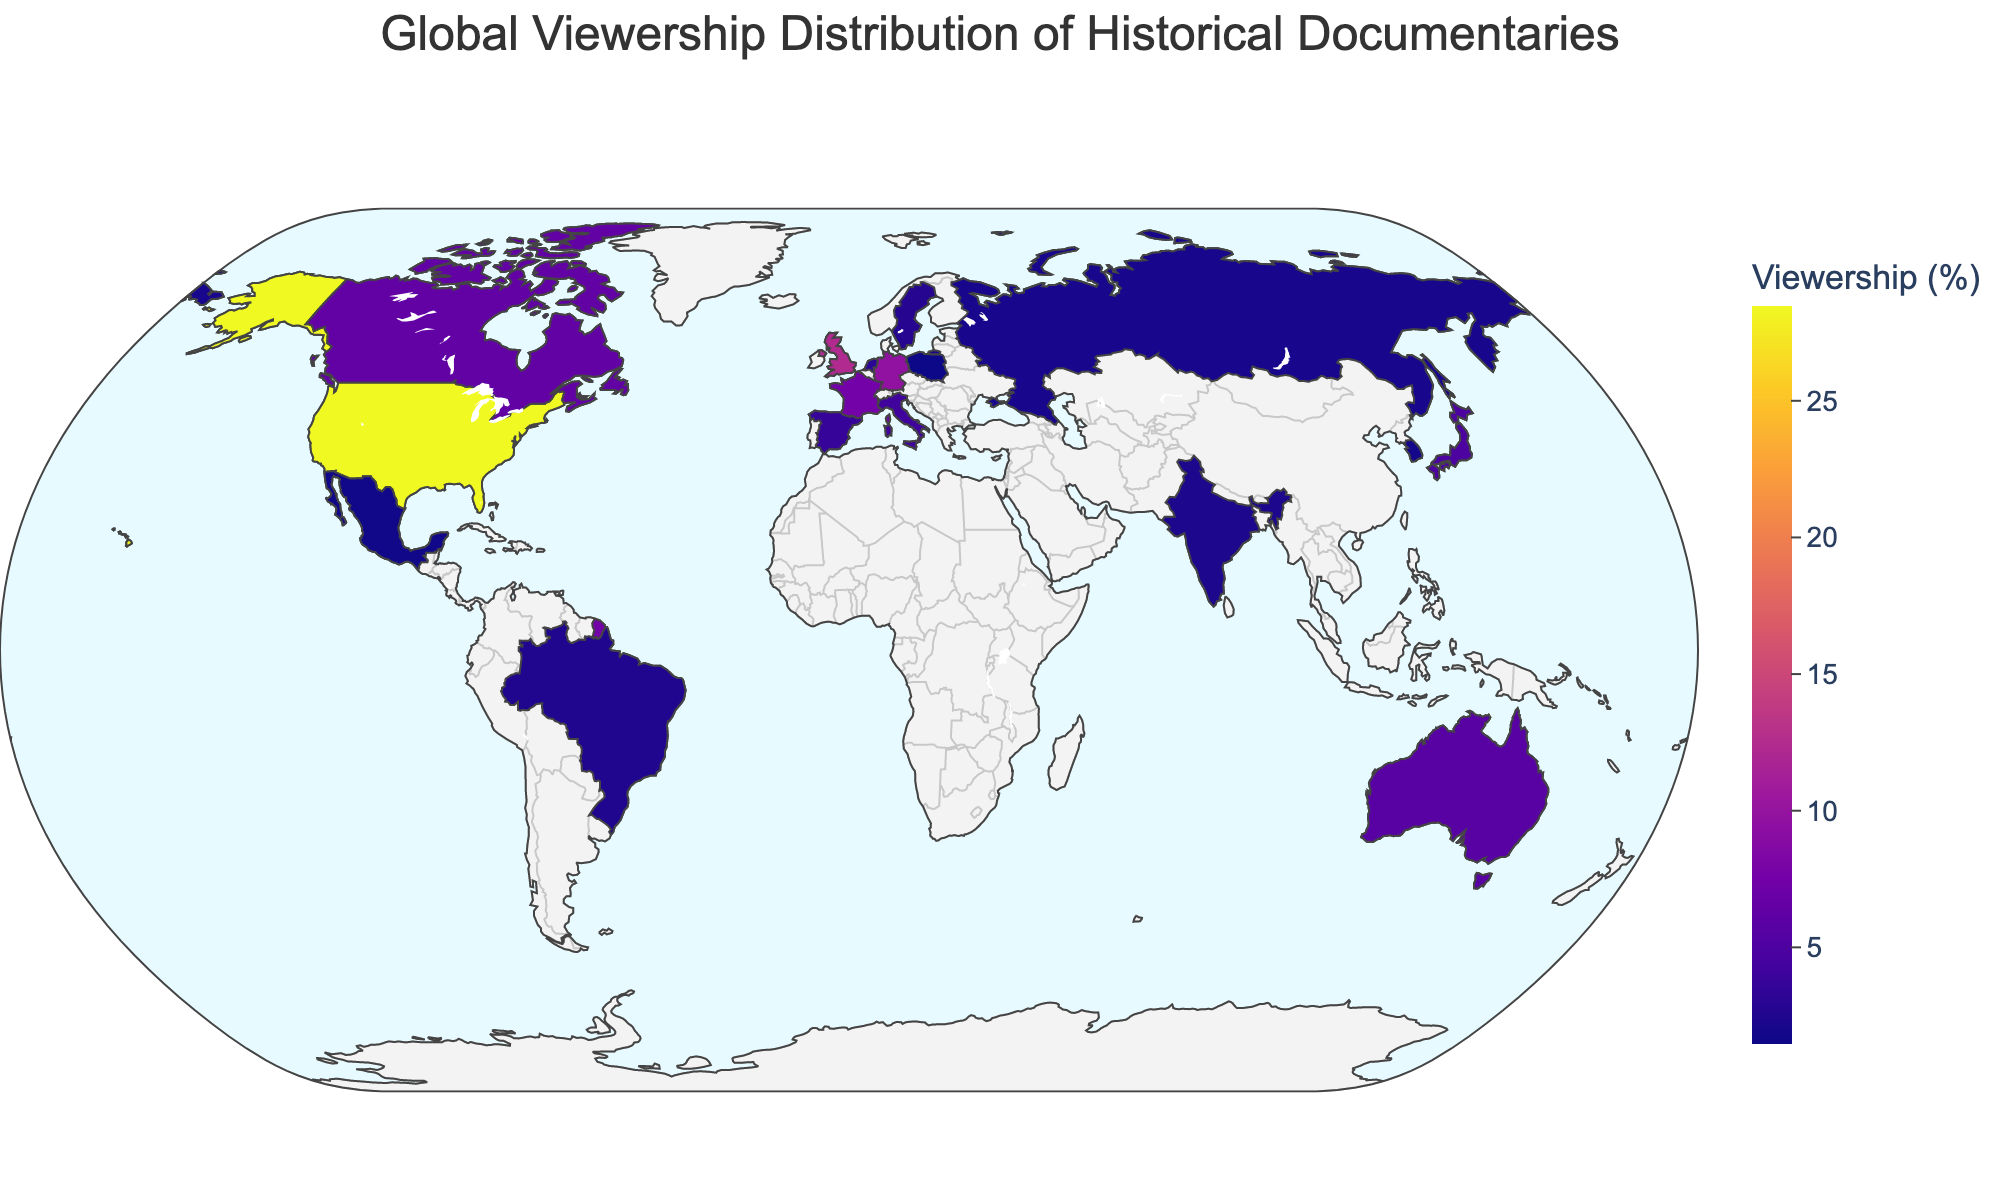What country has the highest percentage of viewership? Look for the country with the darkest color (or highest value) on the map. The US has the darkest shade.
Answer: United States What is the title of the figure? Read the title displayed at the top of the figure.
Answer: Global Viewership Distribution of Historical Documentaries Which two countries have nearly the same percentage of viewership, around 3%? Identify countries with viewership percentages closest to 3% from the map and the color legend. Netherlands (3.1%) and Sweden (2.8%) are close to 3%.
Answer: Netherlands, Sweden What is the combined viewership percentage for Germany and France? Add Germany's percentage (9.7%) to France's percentage (7.6%). 9.7 + 7.6 = 17.3%
Answer: 17.3% Which country has a viewership percentage of 1.9%? Find the country labeled with 1.9% on the map.
Answer: South Korea How does Canada's viewership percentage compare to Australia's? Compare the viewership percentages of Canada (6.4%) and Australia (5.8%).
Answer: Canada has a higher percentage What is the average viewership percentage of the countries with the lowest three percentages? Determine the three lowest percentages: Poland (1.5%), Mexico (1.7%), and South Korea (1.9%). Calculate their average: (1.5 + 1.7 + 1.9) / 3 = 1.7%
Answer: 1.7% What percentage of the viewership does Japan contribute? Locate Japan and read its corresponding percentage value on the map.
Answer: 4.9% Which region appears to contribute more to viewership, North America or Europe? Sum the viewership percentages for North American countries (US, Canada, Mexico) and European countries (UK, Germany, France, Italy, Spain, Netherlands, Sweden, Poland). Compare the sums: North America (28.5 + 6.4 + 1.7 = 36.6%) vs Europe (12.3 + 9.7 + 7.6 + 4.2 + 3.7 + 3.1 + 2.8 + 1.5 = 44.9%).
Answer: Europe What is the difference in viewership percentage between the United Kingdom and Italy? Subtract Italy's percentage (4.2%) from the United Kingdom's percentage (12.3%). 12.3 - 4.2 = 8.1%
Answer: 8.1% 